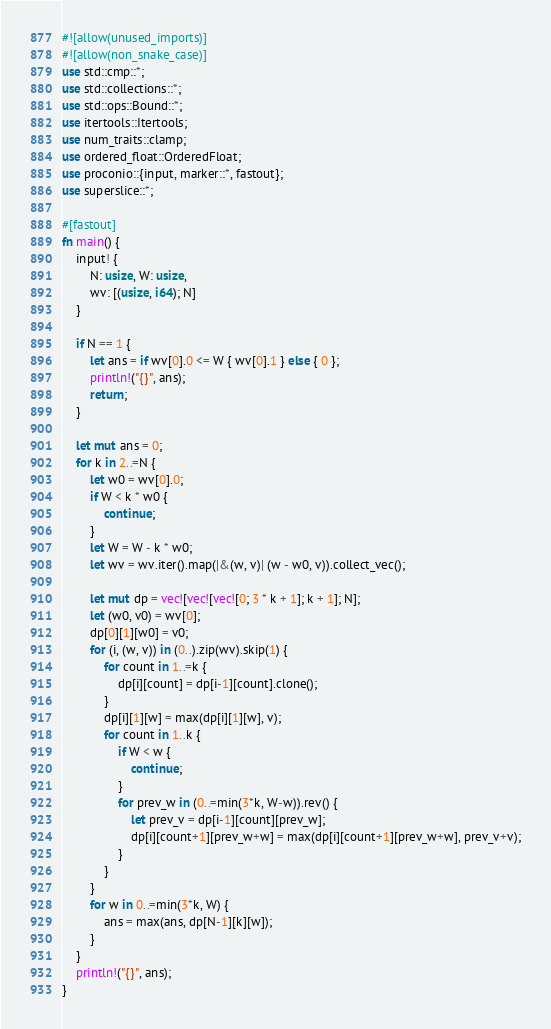<code> <loc_0><loc_0><loc_500><loc_500><_Rust_>#![allow(unused_imports)]
#![allow(non_snake_case)]
use std::cmp::*;
use std::collections::*;
use std::ops::Bound::*;
use itertools::Itertools;
use num_traits::clamp;
use ordered_float::OrderedFloat;
use proconio::{input, marker::*, fastout};
use superslice::*;

#[fastout]
fn main() {
    input! {
        N: usize, W: usize,
        wv: [(usize, i64); N]
    }

    if N == 1 {
        let ans = if wv[0].0 <= W { wv[0].1 } else { 0 };
        println!("{}", ans);
        return;
    }

    let mut ans = 0;
    for k in 2..=N {
        let w0 = wv[0].0;
        if W < k * w0 {
            continue;
        }
        let W = W - k * w0;
        let wv = wv.iter().map(|&(w, v)| (w - w0, v)).collect_vec();

        let mut dp = vec![vec![vec![0; 3 * k + 1]; k + 1]; N];
        let (w0, v0) = wv[0];
        dp[0][1][w0] = v0;
        for (i, (w, v)) in (0..).zip(wv).skip(1) {
            for count in 1..=k {
                dp[i][count] = dp[i-1][count].clone();
            }
            dp[i][1][w] = max(dp[i][1][w], v);
            for count in 1..k {
                if W < w {
                    continue;
                }
                for prev_w in (0..=min(3*k, W-w)).rev() {
                    let prev_v = dp[i-1][count][prev_w];
                    dp[i][count+1][prev_w+w] = max(dp[i][count+1][prev_w+w], prev_v+v);
                }
            }
        }
        for w in 0..=min(3*k, W) {
            ans = max(ans, dp[N-1][k][w]);
        }
    }
    println!("{}", ans);
}
</code> 